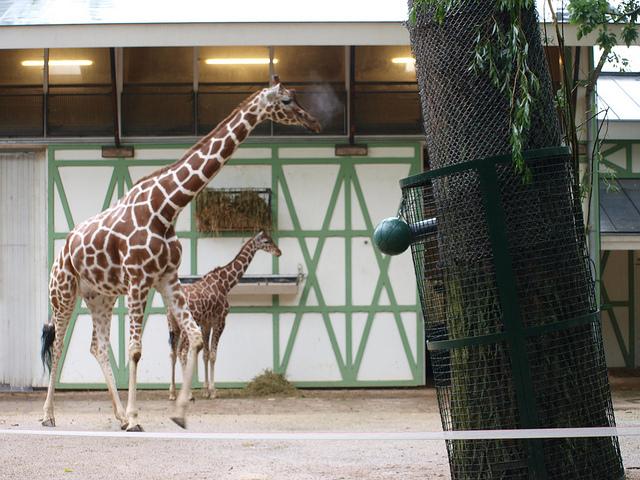How many giraffes?
Give a very brief answer. 2. Are these giraffes free to leave?
Write a very short answer. No. Could the smaller giraffe reach the hay mounted on the wall?
Quick response, please. Yes. 